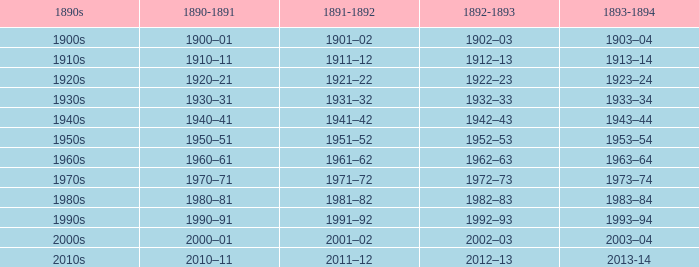What is the year from 1891-92 from the years 1890s to the 1960s? 1961–62. 